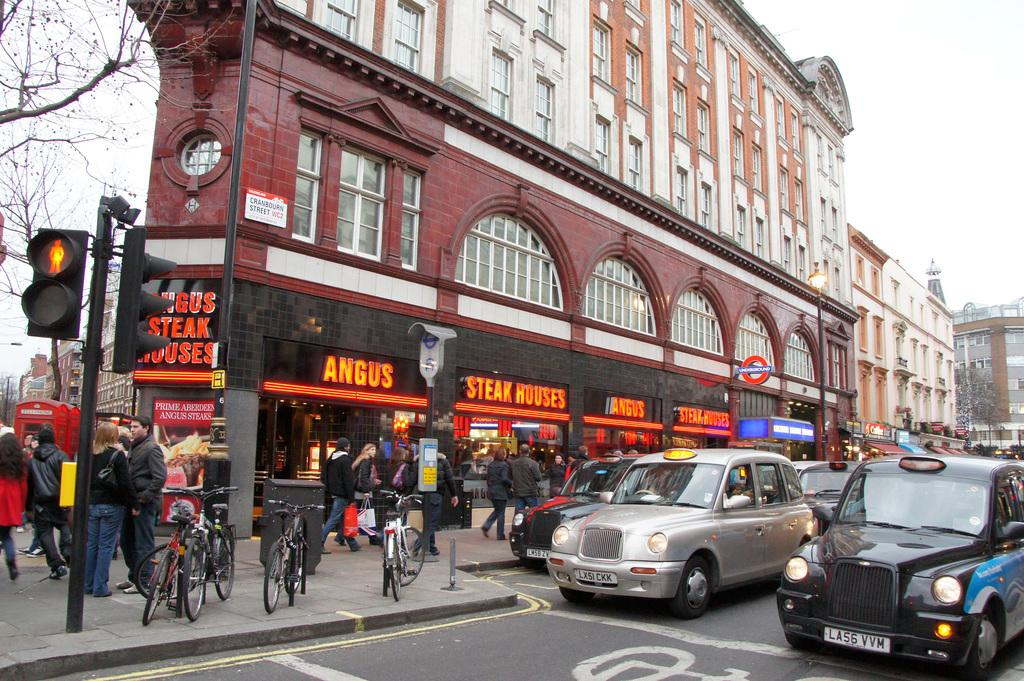<image>
Give a short and clear explanation of the subsequent image. A restaurant on a street corner named angus steak house. 